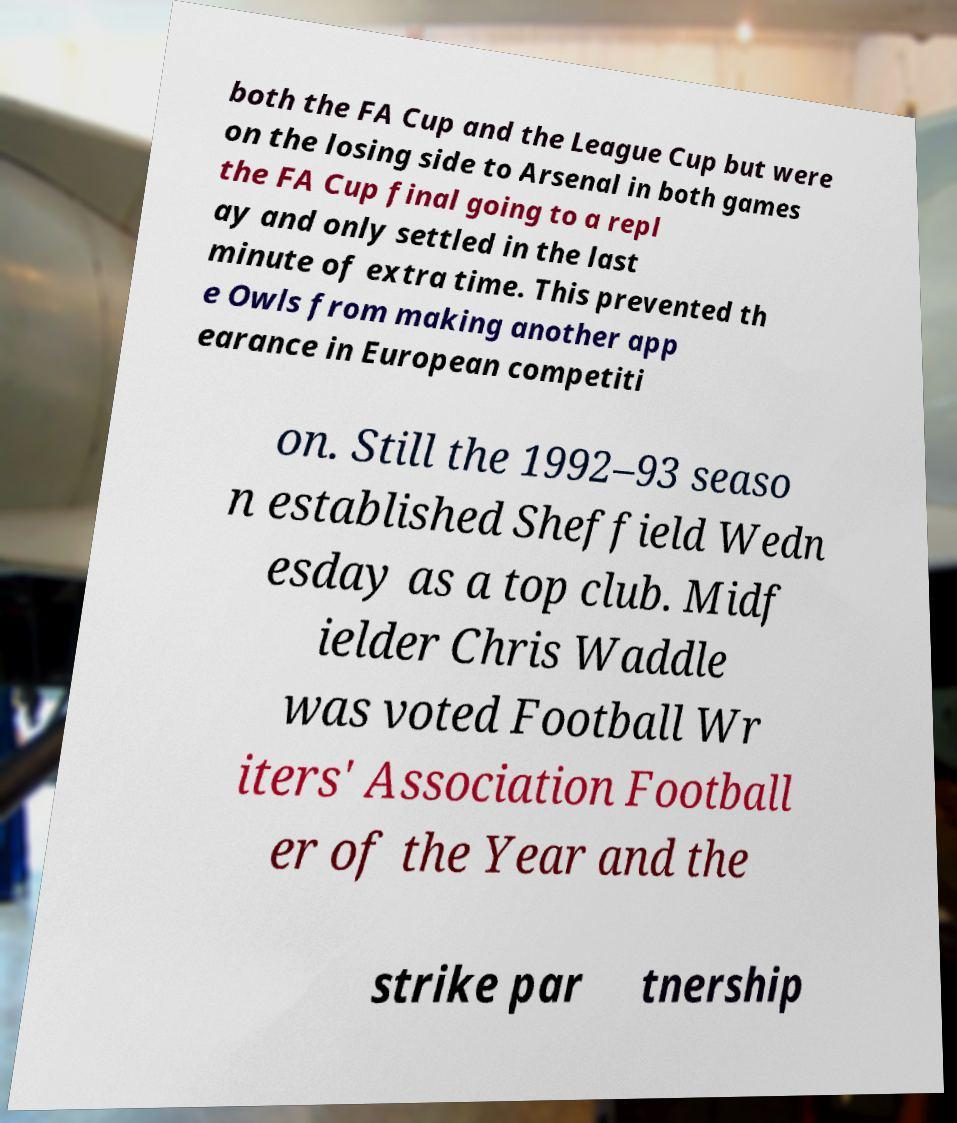There's text embedded in this image that I need extracted. Can you transcribe it verbatim? both the FA Cup and the League Cup but were on the losing side to Arsenal in both games the FA Cup final going to a repl ay and only settled in the last minute of extra time. This prevented th e Owls from making another app earance in European competiti on. Still the 1992–93 seaso n established Sheffield Wedn esday as a top club. Midf ielder Chris Waddle was voted Football Wr iters' Association Football er of the Year and the strike par tnership 